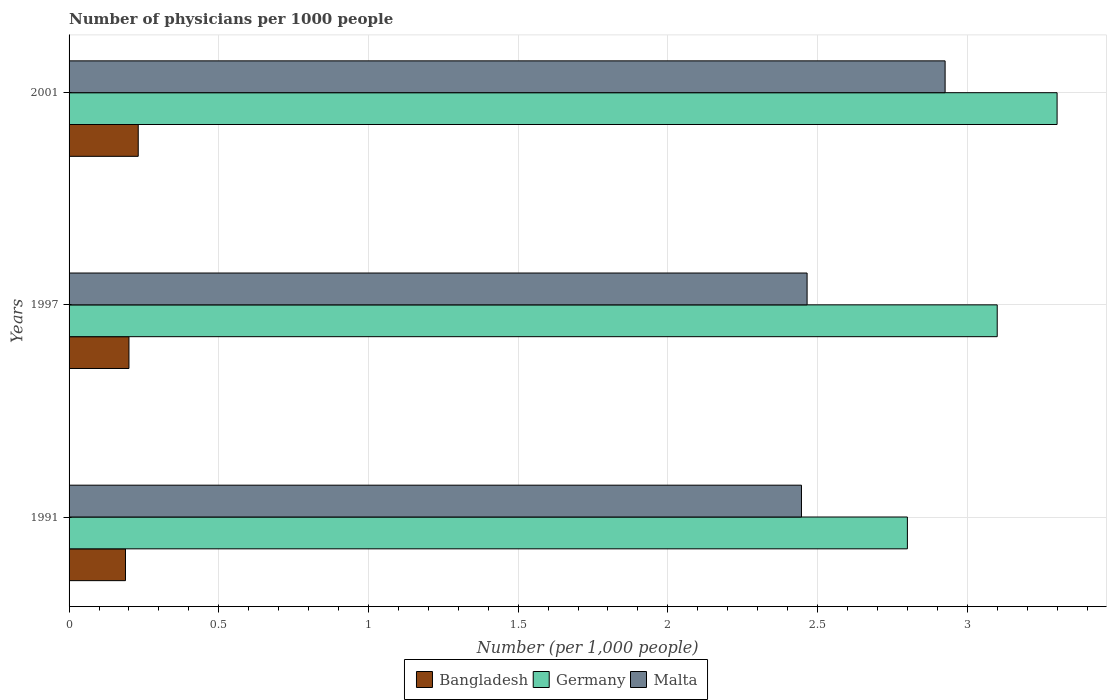Are the number of bars per tick equal to the number of legend labels?
Your answer should be compact. Yes. Are the number of bars on each tick of the Y-axis equal?
Make the answer very short. Yes. How many bars are there on the 2nd tick from the top?
Your response must be concise. 3. How many bars are there on the 1st tick from the bottom?
Provide a succinct answer. 3. In how many cases, is the number of bars for a given year not equal to the number of legend labels?
Provide a short and direct response. 0. What is the number of physicians in Germany in 2001?
Your answer should be very brief. 3.3. Across all years, what is the maximum number of physicians in Malta?
Give a very brief answer. 2.93. Across all years, what is the minimum number of physicians in Bangladesh?
Ensure brevity in your answer.  0.19. In which year was the number of physicians in Germany maximum?
Keep it short and to the point. 2001. In which year was the number of physicians in Germany minimum?
Offer a terse response. 1991. What is the total number of physicians in Germany in the graph?
Your answer should be compact. 9.2. What is the difference between the number of physicians in Malta in 1991 and that in 1997?
Keep it short and to the point. -0.02. What is the difference between the number of physicians in Malta in 1991 and the number of physicians in Bangladesh in 1997?
Keep it short and to the point. 2.25. What is the average number of physicians in Malta per year?
Ensure brevity in your answer.  2.61. In the year 1991, what is the difference between the number of physicians in Bangladesh and number of physicians in Germany?
Your response must be concise. -2.61. What is the ratio of the number of physicians in Malta in 1991 to that in 1997?
Offer a very short reply. 0.99. Is the number of physicians in Malta in 1991 less than that in 2001?
Your answer should be compact. Yes. What is the difference between the highest and the second highest number of physicians in Germany?
Your answer should be compact. 0.2. What is the difference between the highest and the lowest number of physicians in Germany?
Make the answer very short. 0.5. In how many years, is the number of physicians in Malta greater than the average number of physicians in Malta taken over all years?
Make the answer very short. 1. What does the 1st bar from the top in 1991 represents?
Your answer should be very brief. Malta. What does the 1st bar from the bottom in 1997 represents?
Keep it short and to the point. Bangladesh. How many bars are there?
Your response must be concise. 9. Does the graph contain grids?
Offer a very short reply. Yes. How many legend labels are there?
Offer a terse response. 3. How are the legend labels stacked?
Make the answer very short. Horizontal. What is the title of the graph?
Keep it short and to the point. Number of physicians per 1000 people. What is the label or title of the X-axis?
Offer a terse response. Number (per 1,0 people). What is the label or title of the Y-axis?
Offer a terse response. Years. What is the Number (per 1,000 people) in Bangladesh in 1991?
Your answer should be very brief. 0.19. What is the Number (per 1,000 people) of Germany in 1991?
Your answer should be very brief. 2.8. What is the Number (per 1,000 people) in Malta in 1991?
Make the answer very short. 2.45. What is the Number (per 1,000 people) in Germany in 1997?
Your response must be concise. 3.1. What is the Number (per 1,000 people) of Malta in 1997?
Keep it short and to the point. 2.46. What is the Number (per 1,000 people) of Bangladesh in 2001?
Your answer should be compact. 0.23. What is the Number (per 1,000 people) of Germany in 2001?
Make the answer very short. 3.3. What is the Number (per 1,000 people) of Malta in 2001?
Offer a very short reply. 2.93. Across all years, what is the maximum Number (per 1,000 people) of Bangladesh?
Offer a very short reply. 0.23. Across all years, what is the maximum Number (per 1,000 people) in Germany?
Your answer should be compact. 3.3. Across all years, what is the maximum Number (per 1,000 people) in Malta?
Make the answer very short. 2.93. Across all years, what is the minimum Number (per 1,000 people) of Bangladesh?
Your response must be concise. 0.19. Across all years, what is the minimum Number (per 1,000 people) in Malta?
Your answer should be compact. 2.45. What is the total Number (per 1,000 people) of Bangladesh in the graph?
Give a very brief answer. 0.62. What is the total Number (per 1,000 people) of Germany in the graph?
Your response must be concise. 9.2. What is the total Number (per 1,000 people) in Malta in the graph?
Provide a short and direct response. 7.84. What is the difference between the Number (per 1,000 people) in Bangladesh in 1991 and that in 1997?
Provide a succinct answer. -0.01. What is the difference between the Number (per 1,000 people) of Germany in 1991 and that in 1997?
Provide a succinct answer. -0.3. What is the difference between the Number (per 1,000 people) in Malta in 1991 and that in 1997?
Give a very brief answer. -0.02. What is the difference between the Number (per 1,000 people) in Bangladesh in 1991 and that in 2001?
Provide a short and direct response. -0.04. What is the difference between the Number (per 1,000 people) in Germany in 1991 and that in 2001?
Offer a terse response. -0.5. What is the difference between the Number (per 1,000 people) in Malta in 1991 and that in 2001?
Your answer should be very brief. -0.48. What is the difference between the Number (per 1,000 people) of Bangladesh in 1997 and that in 2001?
Provide a short and direct response. -0.03. What is the difference between the Number (per 1,000 people) in Germany in 1997 and that in 2001?
Provide a short and direct response. -0.2. What is the difference between the Number (per 1,000 people) of Malta in 1997 and that in 2001?
Keep it short and to the point. -0.46. What is the difference between the Number (per 1,000 people) in Bangladesh in 1991 and the Number (per 1,000 people) in Germany in 1997?
Keep it short and to the point. -2.91. What is the difference between the Number (per 1,000 people) in Bangladesh in 1991 and the Number (per 1,000 people) in Malta in 1997?
Make the answer very short. -2.28. What is the difference between the Number (per 1,000 people) of Germany in 1991 and the Number (per 1,000 people) of Malta in 1997?
Your answer should be compact. 0.34. What is the difference between the Number (per 1,000 people) of Bangladesh in 1991 and the Number (per 1,000 people) of Germany in 2001?
Offer a very short reply. -3.11. What is the difference between the Number (per 1,000 people) in Bangladesh in 1991 and the Number (per 1,000 people) in Malta in 2001?
Your answer should be compact. -2.74. What is the difference between the Number (per 1,000 people) of Germany in 1991 and the Number (per 1,000 people) of Malta in 2001?
Your response must be concise. -0.13. What is the difference between the Number (per 1,000 people) of Bangladesh in 1997 and the Number (per 1,000 people) of Malta in 2001?
Provide a succinct answer. -2.73. What is the difference between the Number (per 1,000 people) of Germany in 1997 and the Number (per 1,000 people) of Malta in 2001?
Offer a very short reply. 0.17. What is the average Number (per 1,000 people) in Bangladesh per year?
Your answer should be very brief. 0.21. What is the average Number (per 1,000 people) of Germany per year?
Your answer should be compact. 3.07. What is the average Number (per 1,000 people) of Malta per year?
Offer a very short reply. 2.61. In the year 1991, what is the difference between the Number (per 1,000 people) in Bangladesh and Number (per 1,000 people) in Germany?
Provide a short and direct response. -2.61. In the year 1991, what is the difference between the Number (per 1,000 people) in Bangladesh and Number (per 1,000 people) in Malta?
Your answer should be compact. -2.26. In the year 1991, what is the difference between the Number (per 1,000 people) of Germany and Number (per 1,000 people) of Malta?
Keep it short and to the point. 0.35. In the year 1997, what is the difference between the Number (per 1,000 people) in Bangladesh and Number (per 1,000 people) in Germany?
Your answer should be compact. -2.9. In the year 1997, what is the difference between the Number (per 1,000 people) in Bangladesh and Number (per 1,000 people) in Malta?
Your answer should be very brief. -2.27. In the year 1997, what is the difference between the Number (per 1,000 people) in Germany and Number (per 1,000 people) in Malta?
Provide a succinct answer. 0.64. In the year 2001, what is the difference between the Number (per 1,000 people) of Bangladesh and Number (per 1,000 people) of Germany?
Keep it short and to the point. -3.07. In the year 2001, what is the difference between the Number (per 1,000 people) in Bangladesh and Number (per 1,000 people) in Malta?
Your answer should be compact. -2.69. In the year 2001, what is the difference between the Number (per 1,000 people) in Germany and Number (per 1,000 people) in Malta?
Offer a very short reply. 0.37. What is the ratio of the Number (per 1,000 people) of Bangladesh in 1991 to that in 1997?
Offer a very short reply. 0.94. What is the ratio of the Number (per 1,000 people) of Germany in 1991 to that in 1997?
Provide a succinct answer. 0.9. What is the ratio of the Number (per 1,000 people) in Malta in 1991 to that in 1997?
Provide a succinct answer. 0.99. What is the ratio of the Number (per 1,000 people) of Bangladesh in 1991 to that in 2001?
Your answer should be compact. 0.82. What is the ratio of the Number (per 1,000 people) of Germany in 1991 to that in 2001?
Offer a terse response. 0.85. What is the ratio of the Number (per 1,000 people) in Malta in 1991 to that in 2001?
Your answer should be compact. 0.84. What is the ratio of the Number (per 1,000 people) of Bangladesh in 1997 to that in 2001?
Your answer should be very brief. 0.87. What is the ratio of the Number (per 1,000 people) of Germany in 1997 to that in 2001?
Your response must be concise. 0.94. What is the ratio of the Number (per 1,000 people) of Malta in 1997 to that in 2001?
Provide a short and direct response. 0.84. What is the difference between the highest and the second highest Number (per 1,000 people) in Bangladesh?
Give a very brief answer. 0.03. What is the difference between the highest and the second highest Number (per 1,000 people) in Malta?
Provide a succinct answer. 0.46. What is the difference between the highest and the lowest Number (per 1,000 people) in Bangladesh?
Offer a terse response. 0.04. What is the difference between the highest and the lowest Number (per 1,000 people) of Malta?
Keep it short and to the point. 0.48. 